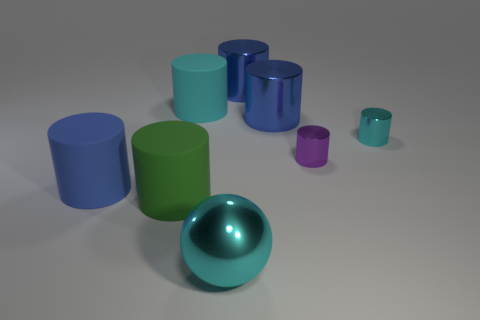How many objects are there in total, and can you describe their colors? In the image, there are a total of seven objects. Starting from the left, there is a blue cylinder, followed by a green one, two cyan cylinders, and a purple cylinder. In front of these cylinders is a larger cyan sphere, and to the right is a smaller cyan cylinder. 